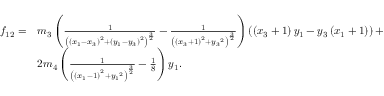Convert formula to latex. <formula><loc_0><loc_0><loc_500><loc_500>\begin{array} { l l } { f _ { 1 2 } = } & { { m _ { 3 } } \left ( \frac { 1 } { \left ( \left ( { x _ { 1 } } - { x _ { 3 } } \right ) ^ { 2 } + \left ( { y _ { 1 } } - { y _ { 3 } } \right ) ^ { 2 } \right ) ^ { \frac { 3 } { 2 } } } - \frac { 1 } { \left ( \left ( { x _ { 3 } } + 1 \right ) ^ { 2 } + { y _ { 3 } } ^ { 2 } \right ) ^ { \frac { 3 } { 2 } } } \right ) \left ( \left ( { x _ { 3 } } + 1 \right ) { y _ { 1 } } - { y _ { 3 } } \left ( { x _ { 1 } } + 1 \right ) \right ) + } \\ & { 2 { m _ { 4 } } \left ( \frac { 1 } { \left ( \left ( { x _ { 1 } } - 1 \right ) ^ { 2 } + { y _ { 1 } } ^ { 2 } \right ) ^ { \frac { 3 } { 2 } } } - \frac { 1 } { 8 } \right ) { y _ { 1 } } . } \end{array}</formula> 